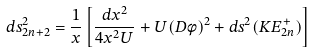Convert formula to latex. <formula><loc_0><loc_0><loc_500><loc_500>d s ^ { 2 } _ { 2 n + 2 } = \frac { 1 } { x } \left [ \frac { d x ^ { 2 } } { 4 x ^ { 2 } U } + U ( D \phi ) ^ { 2 } + d s ^ { 2 } ( K E ^ { + } _ { 2 n } ) \right ]</formula> 